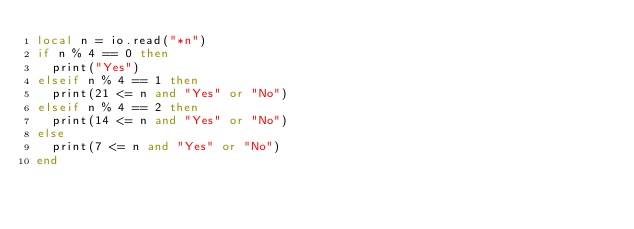<code> <loc_0><loc_0><loc_500><loc_500><_Lua_>local n = io.read("*n")
if n % 4 == 0 then
  print("Yes")
elseif n % 4 == 1 then
  print(21 <= n and "Yes" or "No")
elseif n % 4 == 2 then
  print(14 <= n and "Yes" or "No")
else
  print(7 <= n and "Yes" or "No")
end
</code> 